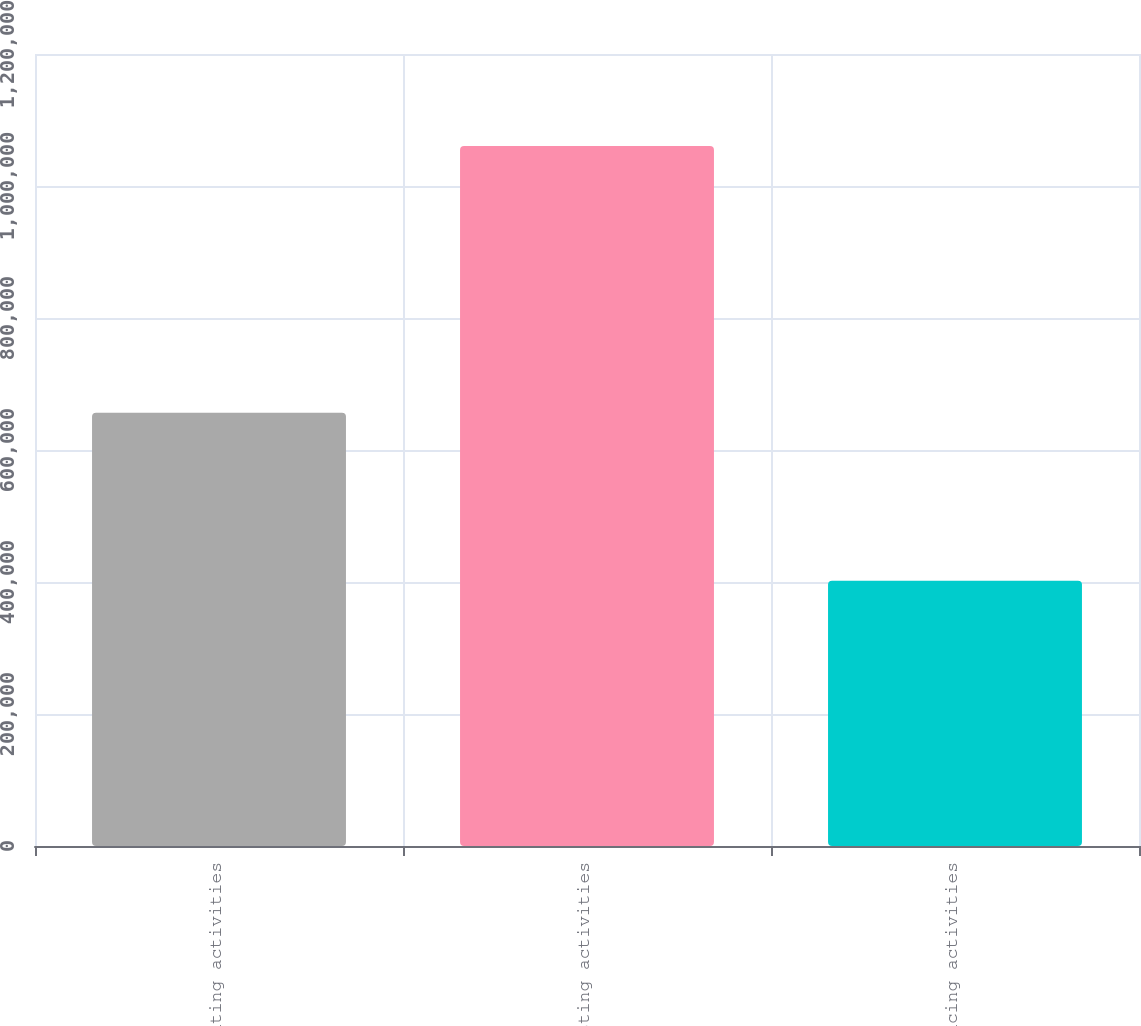Convert chart to OTSL. <chart><loc_0><loc_0><loc_500><loc_500><bar_chart><fcel>Operating activities<fcel>Investing activities<fcel>Financing activities<nl><fcel>656390<fcel>1.06061e+06<fcel>401832<nl></chart> 